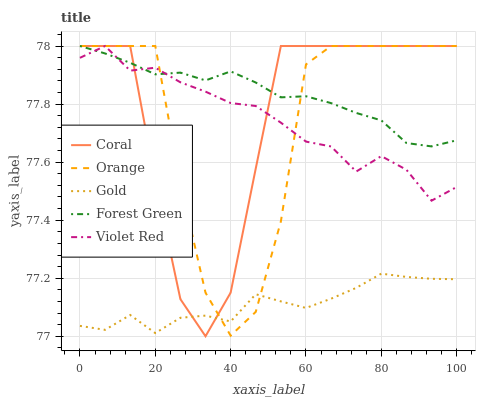Does Violet Red have the minimum area under the curve?
Answer yes or no. No. Does Violet Red have the maximum area under the curve?
Answer yes or no. No. Is Violet Red the smoothest?
Answer yes or no. No. Is Violet Red the roughest?
Answer yes or no. No. Does Violet Red have the lowest value?
Answer yes or no. No. Does Gold have the highest value?
Answer yes or no. No. Is Gold less than Forest Green?
Answer yes or no. Yes. Is Forest Green greater than Gold?
Answer yes or no. Yes. Does Gold intersect Forest Green?
Answer yes or no. No. 